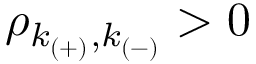Convert formula to latex. <formula><loc_0><loc_0><loc_500><loc_500>\rho _ { k _ { ( + ) } , k _ { ( - ) } } > 0</formula> 